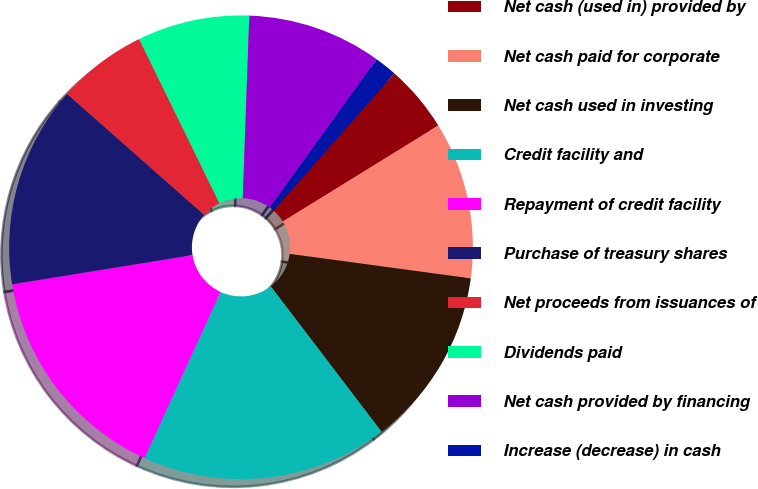Convert chart to OTSL. <chart><loc_0><loc_0><loc_500><loc_500><pie_chart><fcel>Net cash (used in) provided by<fcel>Net cash paid for corporate<fcel>Net cash used in investing<fcel>Credit facility and<fcel>Repayment of credit facility<fcel>Purchase of treasury shares<fcel>Net proceeds from issuances of<fcel>Dividends paid<fcel>Net cash provided by financing<fcel>Increase (decrease) in cash<nl><fcel>4.69%<fcel>10.94%<fcel>12.5%<fcel>17.19%<fcel>15.62%<fcel>14.06%<fcel>6.25%<fcel>7.81%<fcel>9.38%<fcel>1.56%<nl></chart> 